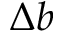<formula> <loc_0><loc_0><loc_500><loc_500>\Delta b</formula> 